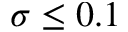Convert formula to latex. <formula><loc_0><loc_0><loc_500><loc_500>\sigma \leq 0 . 1</formula> 